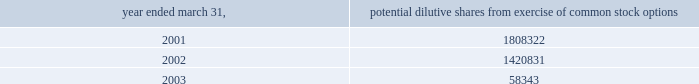( i ) intellectual property the company capitalizes as intellectual property costs incurred , excluding costs associated with company personnel , relating to patenting its technology .
Capitalized costs , the majority of which represent legal costs , reflect the cost of both awarded patents and patents pending .
The company amortizes the cost of these patents on a straight-line basis over a period of seven years .
If the company elects to stop pursuing a particular patent application or determines that a patent application is not likely to be awarded for a particular patent or elects to discontinue payment of required maintenance fees for a particular patent , the company at that time records as expense the net capitalized amount of such patent application or patent .
The company does not capitalize maintenance fees for patents .
( j ) net loss per share basic net loss per share is computed by dividing net loss by the weighted-average number of common shares outstanding during the fiscal year .
Diluted net loss per share is computed by dividing net loss by the weighted-average number of dilutive common shares outstanding during the fiscal year .
Diluted weighted-average shares reflect the dilutive effect , if any , of potential common stock such as options and warrants based on the treasury stock method .
No potential common stock is considered dilutive in periods in which a loss is reported , such as the fiscal years ended march 31 , 2001 , 2002 and 2003 , because all such common equivalent shares would be antidilutive .
The calculation of diluted weighted-average shares outstanding for the years ended march 31 , 2001 , 2002 and 2003 excludes the options to purchase common stock as shown below .
Potential dilutive shares year ended march 31 , from exercise of common stock options .
The calculation of diluted weighted-average shares outstanding excludes unissued shares of common stock associated with outstanding stock options that have exercise prices greater than the average market price of abiomed common stock during the period .
For the fiscal years ending march 31 , 2001 , 2002 and 2003 , the weighted-average number of these potential shares totaled 61661 , 341495 and 2463715 shares , respectively .
The calculation of diluted weighted-average shares outstanding for the years ended march 31 , 2001 , 2002 and 2003 also excludes warrants to purchase 400000 shares of common stock issued in connection with the acquisition of intellectual property ( see note 4 ) .
( k ) cash and cash equivalents the company classifies any marketable security with a maturity date of 90 days or less at the time of purchase as a cash equivalent .
( l ) marketable securities the company classifies any security with a maturity date of greater than 90 days at the time of purchase as marketable securities and classifies marketable securities with a maturity date of greater than one year from the balance sheet date as long-term investments .
Under statement of financial accounting standards ( sfas ) no .
115 , accounting for certain investments in debt and equity securities , securities that the company has the positive intent and ability to hold to maturity are reported at amortized cost and classified as held-to-maturity securities .
The amortized cost and market value of marketable securities were approximately $ 25654000 and $ 25661000 at march 31 , 2002 , and $ 9877000 and $ 9858000 at march 31 , 2003 , respectively .
At march 31 , 2003 , these short-term investments consisted primarily of government securities .
( m ) disclosures about fair value of financial instruments as of march 31 , 2002 and 2003 , the company 2019s financial instruments were comprised of cash and cash equivalents , marketable securities , accounts receivable and accounts payable , the carrying amounts of which approximated fair market value .
( n ) comprehensive income sfas no .
130 , reporting comprehensive income , requires disclosure of all components of comprehensive income and loss on an annual and interim basis .
Comprehensive income and loss is defined as the change in equity of a business enterprise during a period from transactions and other events and circumstances from non-owner sources .
Other than the reported net loss , there were no components of comprehensive income or loss which require disclosure for the years ended march 31 , 2001 , 2002 and 2003 .
Notes to consolidated financial statements ( continued ) march 31 , 2003 page 20 .
What was the unrealized loss in marketable securities at march 31 , 2003? 
Computations: (9858000 - 9877000)
Answer: -19000.0. 